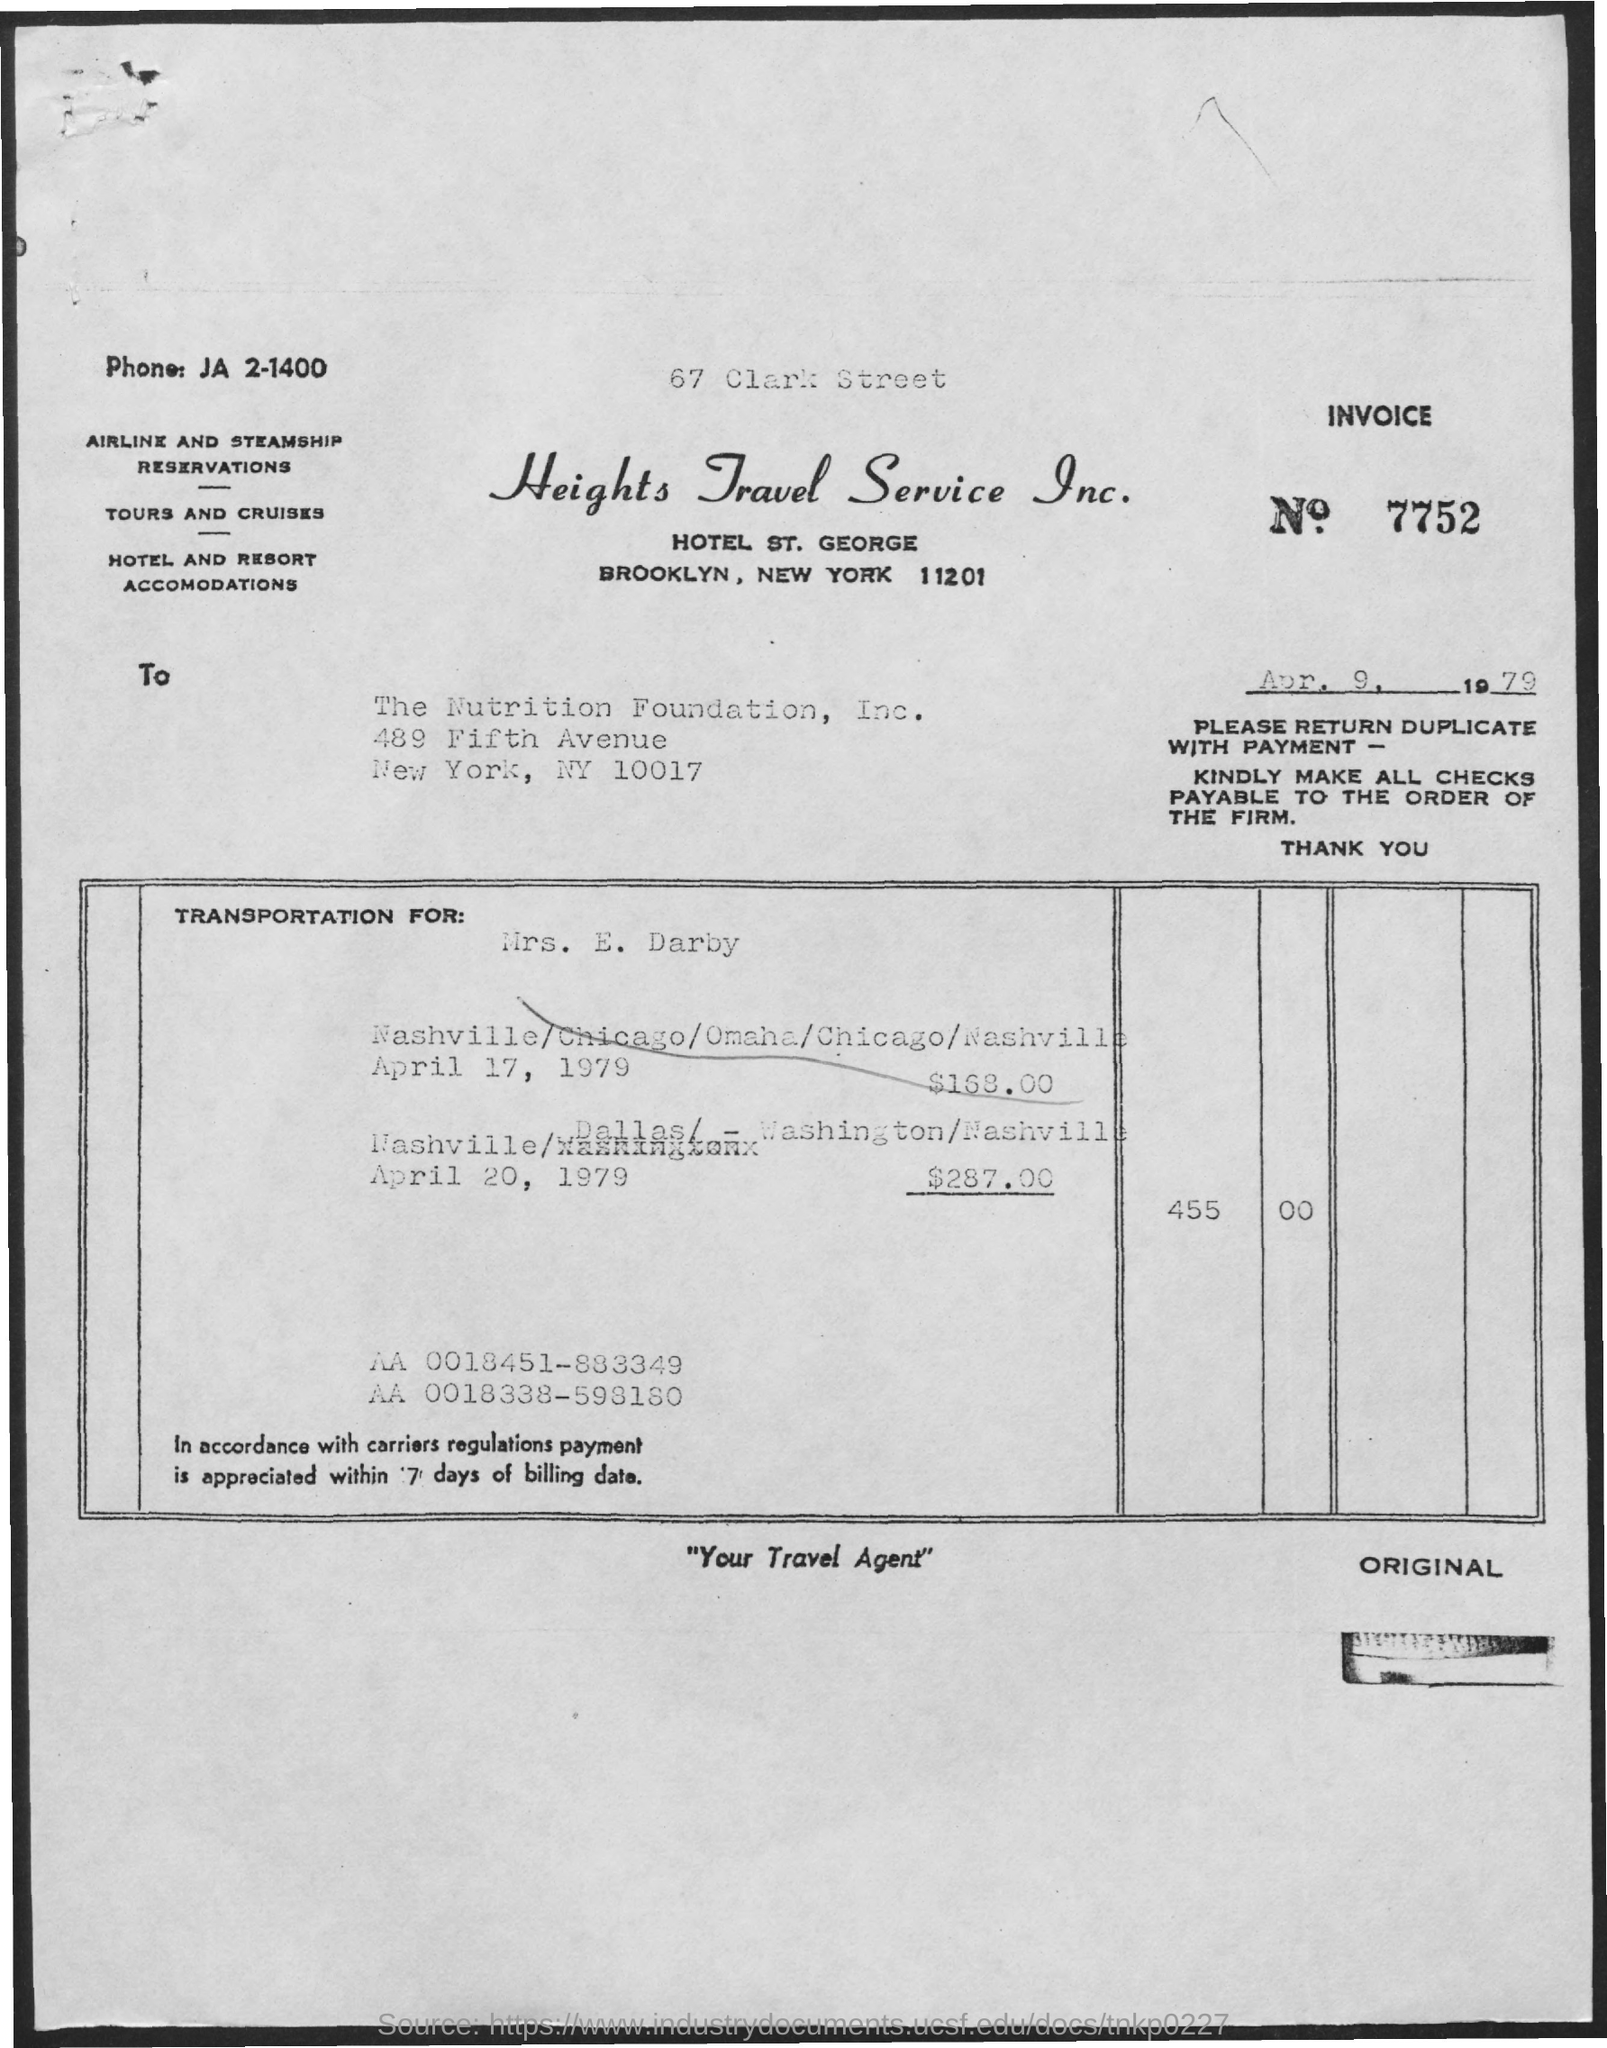What is the Invoice No mentioned in this document?
Your answer should be compact. 7752. What is the phone no mentioned in this document?
Offer a terse response. JA 2-1400. What is the issued date of the invoice?
Give a very brief answer. Apr. 9, 1979. To whom, the invoice is addressed?
Keep it short and to the point. The Nutrition Foundation, Inc. What is the invoice amount on transportation for Mrs. E. Darby dated April 17, 1979?
Your response must be concise. 168.00. What is the invoice amount on transportation for Mrs. E. Darby  dated April 20, 1979?
Your response must be concise. 287.00. 